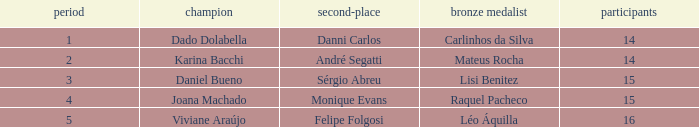Who was the winner when Mateus Rocha finished in 3rd place?  Karina Bacchi. 